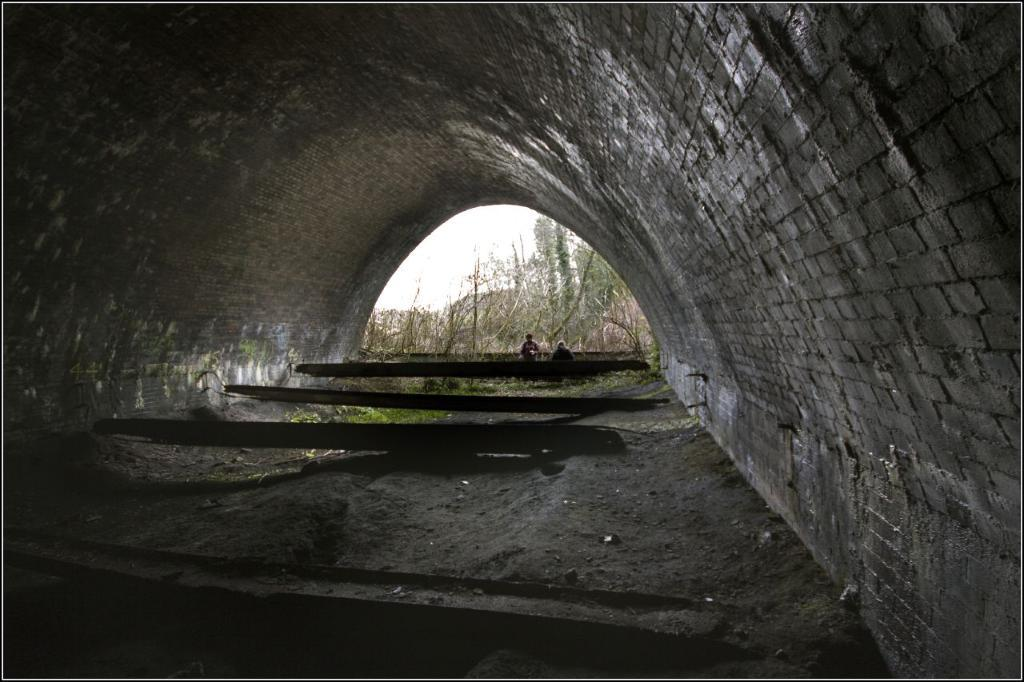What is the main feature of the image? There is a tunnel in the image. What else can be seen on the ground in the image? There are objects on the ground in the image. How many people are present in the image? There are two persons in the image. What can be seen in the background of the image? There are trees and the sky visible in the background of the image. What type of bottle is being used to make the selection in the image? There is no bottle or selection process depicted in the image; it features a tunnel, objects on the ground, two persons, trees, and the sky. 